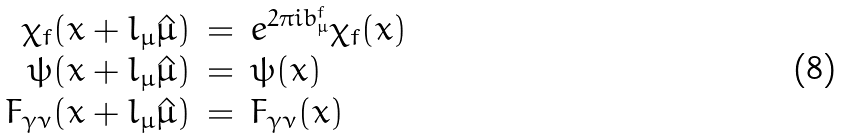<formula> <loc_0><loc_0><loc_500><loc_500>\begin{array} { r c l } \chi _ { f } ( x + l _ { \mu } \hat { \mu } ) & = & e ^ { 2 \pi i b ^ { f } _ { \mu } } \chi _ { f } ( x ) \\ \psi ( x + l _ { \mu } \hat { \mu } ) & = & \psi ( x ) \\ F _ { \gamma \nu } ( x + l _ { \mu } \hat { \mu } ) & = & F _ { \gamma \nu } ( x ) \\ \end{array}</formula> 